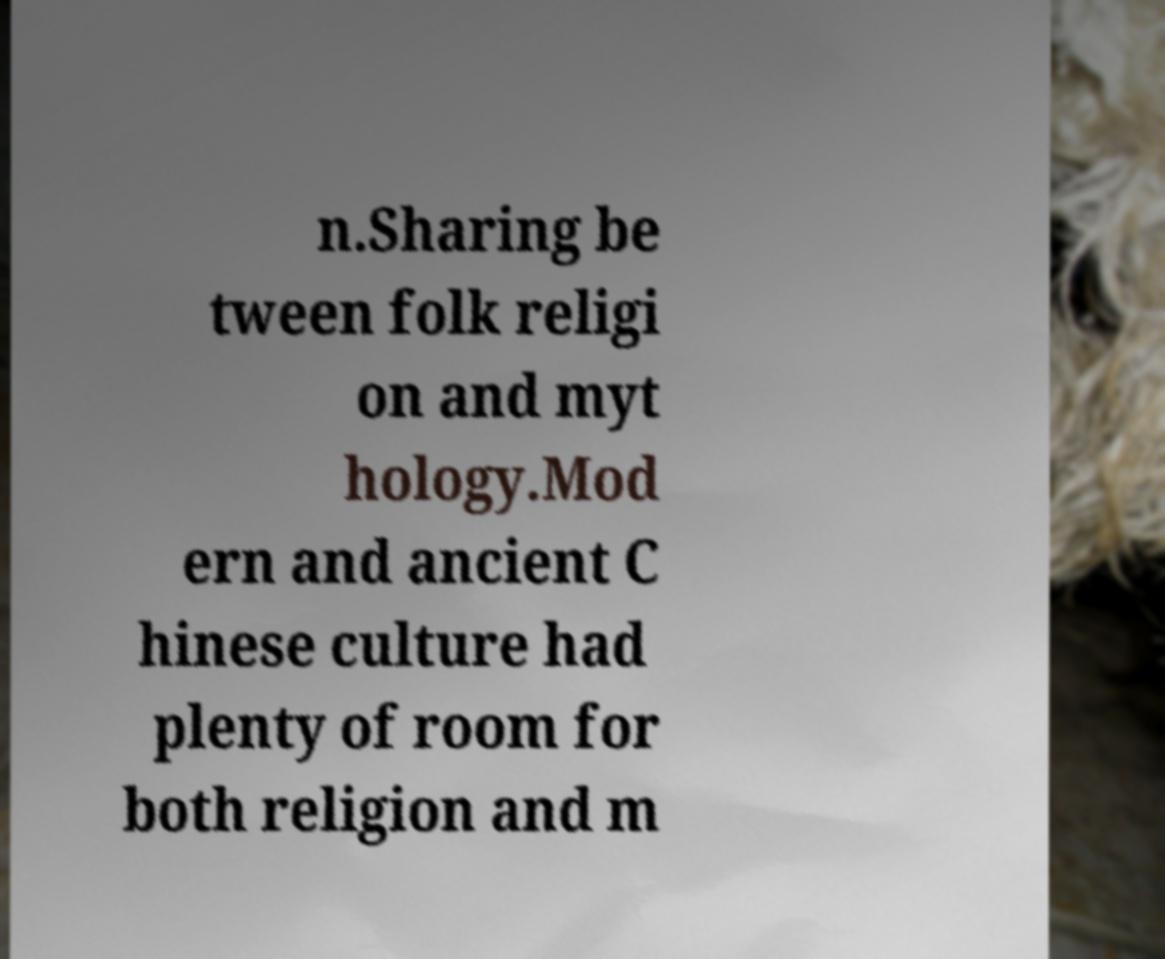Please identify and transcribe the text found in this image. n.Sharing be tween folk religi on and myt hology.Mod ern and ancient C hinese culture had plenty of room for both religion and m 